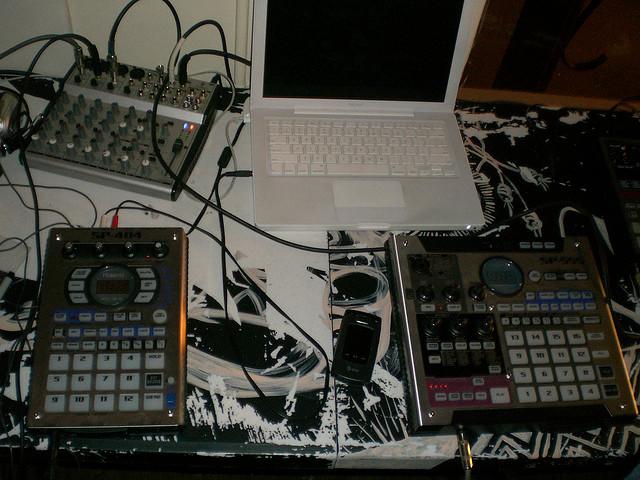Are there any cables?
Quick response, please. Yes. Is there a laptop?
Write a very short answer. Yes. Is the table painted with stripes?
Give a very brief answer. No. Is the laptop on?
Short answer required. No. 